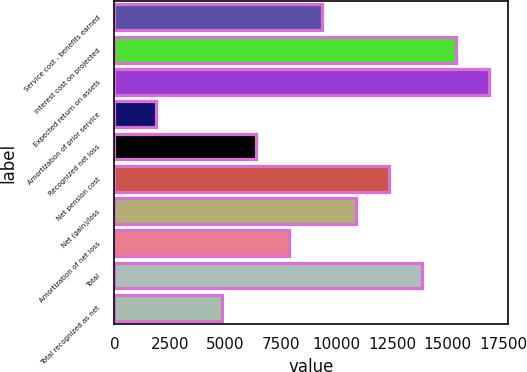Convert chart to OTSL. <chart><loc_0><loc_0><loc_500><loc_500><bar_chart><fcel>Service cost - benefits earned<fcel>Interest cost on projected<fcel>Expected return on assets<fcel>Amortization of prior service<fcel>Recognized net loss<fcel>Net pension cost<fcel>Net (gain)/loss<fcel>Amortization of net loss<fcel>Total<fcel>Total recognized as net<nl><fcel>9353.8<fcel>15349<fcel>16847.8<fcel>1859.8<fcel>6356.2<fcel>12351.4<fcel>10852.6<fcel>7855<fcel>13850.2<fcel>4857.4<nl></chart> 